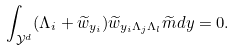<formula> <loc_0><loc_0><loc_500><loc_500>\int _ { \mathcal { Y } ^ { d } } ( \Lambda _ { i } + \widetilde { w } _ { y _ { i } } ) \widetilde { w } _ { y _ { i } \Lambda _ { j } \Lambda _ { l } } \widetilde { m } d y = 0 .</formula> 